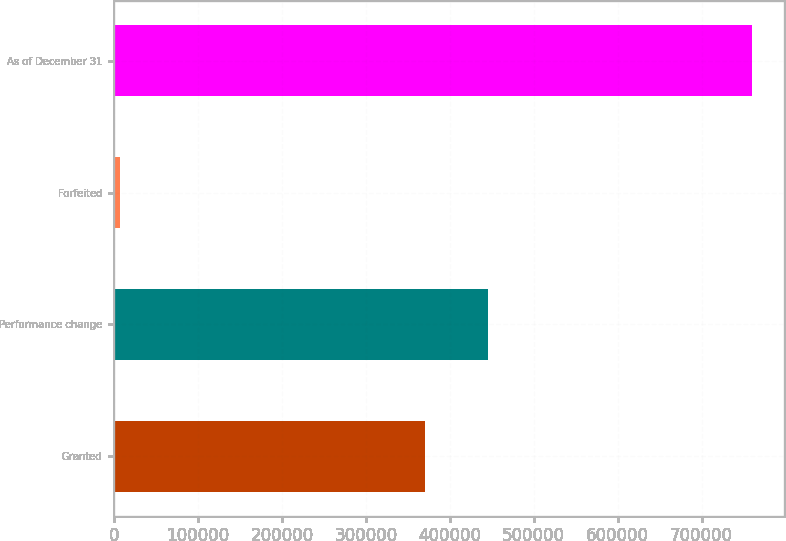Convert chart to OTSL. <chart><loc_0><loc_0><loc_500><loc_500><bar_chart><fcel>Granted<fcel>Performance change<fcel>Forfeited<fcel>As of December 31<nl><fcel>370575<fcel>446008<fcel>6320<fcel>760645<nl></chart> 